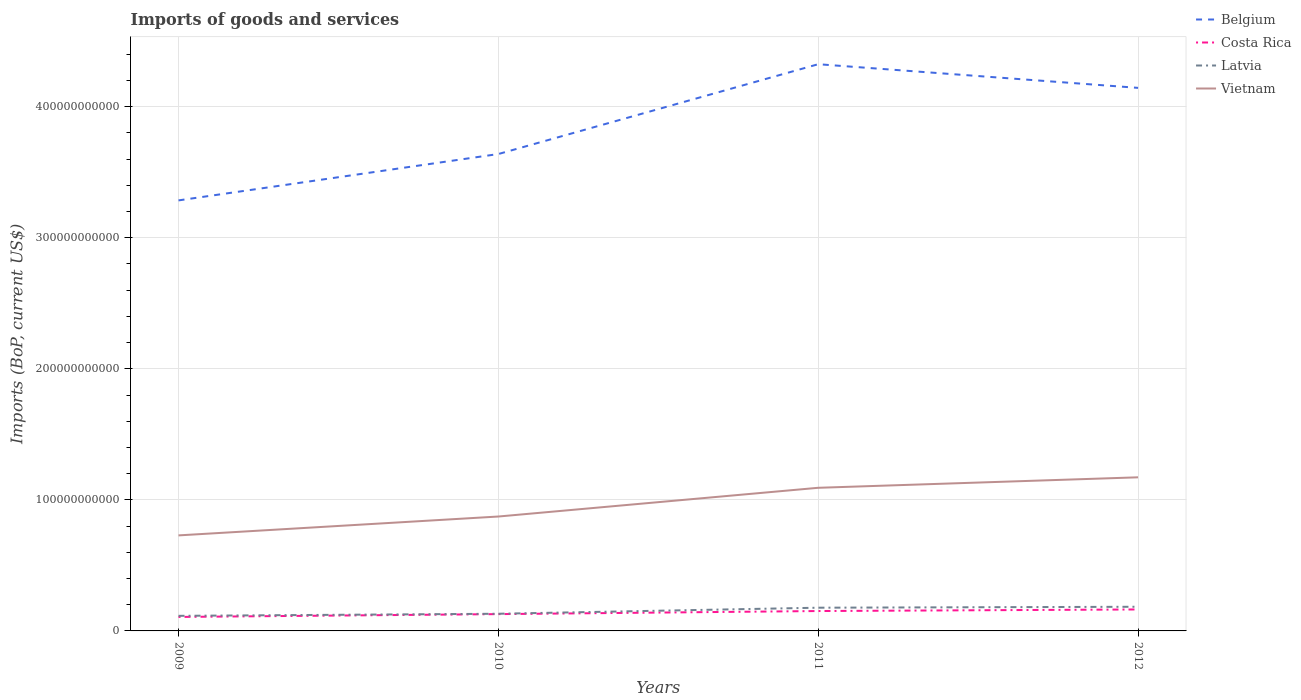How many different coloured lines are there?
Keep it short and to the point. 4. Does the line corresponding to Latvia intersect with the line corresponding to Vietnam?
Offer a very short reply. No. Across all years, what is the maximum amount spent on imports in Vietnam?
Provide a succinct answer. 7.29e+1. What is the total amount spent on imports in Vietnam in the graph?
Ensure brevity in your answer.  -1.44e+1. What is the difference between the highest and the second highest amount spent on imports in Costa Rica?
Offer a terse response. 5.72e+09. Is the amount spent on imports in Vietnam strictly greater than the amount spent on imports in Costa Rica over the years?
Offer a very short reply. No. What is the difference between two consecutive major ticks on the Y-axis?
Your answer should be very brief. 1.00e+11. Are the values on the major ticks of Y-axis written in scientific E-notation?
Your response must be concise. No. Does the graph contain grids?
Your answer should be compact. Yes. Where does the legend appear in the graph?
Provide a succinct answer. Top right. How many legend labels are there?
Make the answer very short. 4. How are the legend labels stacked?
Provide a succinct answer. Vertical. What is the title of the graph?
Offer a terse response. Imports of goods and services. What is the label or title of the Y-axis?
Provide a succinct answer. Imports (BoP, current US$). What is the Imports (BoP, current US$) in Belgium in 2009?
Your answer should be compact. 3.29e+11. What is the Imports (BoP, current US$) of Costa Rica in 2009?
Offer a terse response. 1.07e+1. What is the Imports (BoP, current US$) of Latvia in 2009?
Offer a very short reply. 1.15e+1. What is the Imports (BoP, current US$) in Vietnam in 2009?
Give a very brief answer. 7.29e+1. What is the Imports (BoP, current US$) of Belgium in 2010?
Offer a very short reply. 3.64e+11. What is the Imports (BoP, current US$) in Costa Rica in 2010?
Make the answer very short. 1.28e+1. What is the Imports (BoP, current US$) of Latvia in 2010?
Offer a terse response. 1.31e+1. What is the Imports (BoP, current US$) of Vietnam in 2010?
Offer a very short reply. 8.73e+1. What is the Imports (BoP, current US$) in Belgium in 2011?
Provide a short and direct response. 4.32e+11. What is the Imports (BoP, current US$) in Costa Rica in 2011?
Your answer should be very brief. 1.52e+1. What is the Imports (BoP, current US$) of Latvia in 2011?
Keep it short and to the point. 1.77e+1. What is the Imports (BoP, current US$) of Vietnam in 2011?
Your answer should be compact. 1.09e+11. What is the Imports (BoP, current US$) in Belgium in 2012?
Offer a terse response. 4.14e+11. What is the Imports (BoP, current US$) in Costa Rica in 2012?
Keep it short and to the point. 1.64e+1. What is the Imports (BoP, current US$) in Latvia in 2012?
Your answer should be compact. 1.84e+1. What is the Imports (BoP, current US$) in Vietnam in 2012?
Provide a short and direct response. 1.17e+11. Across all years, what is the maximum Imports (BoP, current US$) in Belgium?
Ensure brevity in your answer.  4.32e+11. Across all years, what is the maximum Imports (BoP, current US$) of Costa Rica?
Provide a succinct answer. 1.64e+1. Across all years, what is the maximum Imports (BoP, current US$) of Latvia?
Give a very brief answer. 1.84e+1. Across all years, what is the maximum Imports (BoP, current US$) of Vietnam?
Provide a succinct answer. 1.17e+11. Across all years, what is the minimum Imports (BoP, current US$) of Belgium?
Your response must be concise. 3.29e+11. Across all years, what is the minimum Imports (BoP, current US$) in Costa Rica?
Provide a succinct answer. 1.07e+1. Across all years, what is the minimum Imports (BoP, current US$) of Latvia?
Offer a terse response. 1.15e+1. Across all years, what is the minimum Imports (BoP, current US$) of Vietnam?
Make the answer very short. 7.29e+1. What is the total Imports (BoP, current US$) of Belgium in the graph?
Give a very brief answer. 1.54e+12. What is the total Imports (BoP, current US$) in Costa Rica in the graph?
Your answer should be compact. 5.50e+1. What is the total Imports (BoP, current US$) in Latvia in the graph?
Ensure brevity in your answer.  6.08e+1. What is the total Imports (BoP, current US$) in Vietnam in the graph?
Give a very brief answer. 3.87e+11. What is the difference between the Imports (BoP, current US$) of Belgium in 2009 and that in 2010?
Make the answer very short. -3.54e+1. What is the difference between the Imports (BoP, current US$) of Costa Rica in 2009 and that in 2010?
Offer a terse response. -2.16e+09. What is the difference between the Imports (BoP, current US$) of Latvia in 2009 and that in 2010?
Provide a short and direct response. -1.59e+09. What is the difference between the Imports (BoP, current US$) of Vietnam in 2009 and that in 2010?
Make the answer very short. -1.44e+1. What is the difference between the Imports (BoP, current US$) in Belgium in 2009 and that in 2011?
Offer a terse response. -1.04e+11. What is the difference between the Imports (BoP, current US$) of Costa Rica in 2009 and that in 2011?
Keep it short and to the point. -4.52e+09. What is the difference between the Imports (BoP, current US$) in Latvia in 2009 and that in 2011?
Your answer should be very brief. -6.20e+09. What is the difference between the Imports (BoP, current US$) of Vietnam in 2009 and that in 2011?
Your response must be concise. -3.63e+1. What is the difference between the Imports (BoP, current US$) in Belgium in 2009 and that in 2012?
Ensure brevity in your answer.  -8.59e+1. What is the difference between the Imports (BoP, current US$) of Costa Rica in 2009 and that in 2012?
Provide a succinct answer. -5.72e+09. What is the difference between the Imports (BoP, current US$) in Latvia in 2009 and that in 2012?
Your answer should be compact. -6.92e+09. What is the difference between the Imports (BoP, current US$) of Vietnam in 2009 and that in 2012?
Give a very brief answer. -4.43e+1. What is the difference between the Imports (BoP, current US$) of Belgium in 2010 and that in 2011?
Offer a very short reply. -6.85e+1. What is the difference between the Imports (BoP, current US$) in Costa Rica in 2010 and that in 2011?
Ensure brevity in your answer.  -2.36e+09. What is the difference between the Imports (BoP, current US$) in Latvia in 2010 and that in 2011?
Your response must be concise. -4.61e+09. What is the difference between the Imports (BoP, current US$) in Vietnam in 2010 and that in 2011?
Make the answer very short. -2.19e+1. What is the difference between the Imports (BoP, current US$) in Belgium in 2010 and that in 2012?
Offer a terse response. -5.05e+1. What is the difference between the Imports (BoP, current US$) in Costa Rica in 2010 and that in 2012?
Offer a terse response. -3.56e+09. What is the difference between the Imports (BoP, current US$) in Latvia in 2010 and that in 2012?
Provide a short and direct response. -5.33e+09. What is the difference between the Imports (BoP, current US$) in Vietnam in 2010 and that in 2012?
Make the answer very short. -2.99e+1. What is the difference between the Imports (BoP, current US$) of Belgium in 2011 and that in 2012?
Offer a terse response. 1.81e+1. What is the difference between the Imports (BoP, current US$) in Costa Rica in 2011 and that in 2012?
Offer a terse response. -1.20e+09. What is the difference between the Imports (BoP, current US$) of Latvia in 2011 and that in 2012?
Provide a short and direct response. -7.21e+08. What is the difference between the Imports (BoP, current US$) of Vietnam in 2011 and that in 2012?
Your response must be concise. -7.99e+09. What is the difference between the Imports (BoP, current US$) of Belgium in 2009 and the Imports (BoP, current US$) of Costa Rica in 2010?
Make the answer very short. 3.16e+11. What is the difference between the Imports (BoP, current US$) of Belgium in 2009 and the Imports (BoP, current US$) of Latvia in 2010?
Offer a terse response. 3.15e+11. What is the difference between the Imports (BoP, current US$) in Belgium in 2009 and the Imports (BoP, current US$) in Vietnam in 2010?
Your response must be concise. 2.41e+11. What is the difference between the Imports (BoP, current US$) of Costa Rica in 2009 and the Imports (BoP, current US$) of Latvia in 2010?
Your answer should be compact. -2.45e+09. What is the difference between the Imports (BoP, current US$) of Costa Rica in 2009 and the Imports (BoP, current US$) of Vietnam in 2010?
Give a very brief answer. -7.66e+1. What is the difference between the Imports (BoP, current US$) of Latvia in 2009 and the Imports (BoP, current US$) of Vietnam in 2010?
Keep it short and to the point. -7.58e+1. What is the difference between the Imports (BoP, current US$) in Belgium in 2009 and the Imports (BoP, current US$) in Costa Rica in 2011?
Your response must be concise. 3.13e+11. What is the difference between the Imports (BoP, current US$) of Belgium in 2009 and the Imports (BoP, current US$) of Latvia in 2011?
Your response must be concise. 3.11e+11. What is the difference between the Imports (BoP, current US$) of Belgium in 2009 and the Imports (BoP, current US$) of Vietnam in 2011?
Keep it short and to the point. 2.19e+11. What is the difference between the Imports (BoP, current US$) in Costa Rica in 2009 and the Imports (BoP, current US$) in Latvia in 2011?
Provide a short and direct response. -7.06e+09. What is the difference between the Imports (BoP, current US$) of Costa Rica in 2009 and the Imports (BoP, current US$) of Vietnam in 2011?
Ensure brevity in your answer.  -9.86e+1. What is the difference between the Imports (BoP, current US$) in Latvia in 2009 and the Imports (BoP, current US$) in Vietnam in 2011?
Provide a short and direct response. -9.77e+1. What is the difference between the Imports (BoP, current US$) of Belgium in 2009 and the Imports (BoP, current US$) of Costa Rica in 2012?
Your answer should be compact. 3.12e+11. What is the difference between the Imports (BoP, current US$) of Belgium in 2009 and the Imports (BoP, current US$) of Latvia in 2012?
Provide a succinct answer. 3.10e+11. What is the difference between the Imports (BoP, current US$) of Belgium in 2009 and the Imports (BoP, current US$) of Vietnam in 2012?
Provide a succinct answer. 2.11e+11. What is the difference between the Imports (BoP, current US$) of Costa Rica in 2009 and the Imports (BoP, current US$) of Latvia in 2012?
Keep it short and to the point. -7.78e+09. What is the difference between the Imports (BoP, current US$) in Costa Rica in 2009 and the Imports (BoP, current US$) in Vietnam in 2012?
Your answer should be very brief. -1.07e+11. What is the difference between the Imports (BoP, current US$) in Latvia in 2009 and the Imports (BoP, current US$) in Vietnam in 2012?
Make the answer very short. -1.06e+11. What is the difference between the Imports (BoP, current US$) of Belgium in 2010 and the Imports (BoP, current US$) of Costa Rica in 2011?
Provide a succinct answer. 3.49e+11. What is the difference between the Imports (BoP, current US$) in Belgium in 2010 and the Imports (BoP, current US$) in Latvia in 2011?
Provide a short and direct response. 3.46e+11. What is the difference between the Imports (BoP, current US$) in Belgium in 2010 and the Imports (BoP, current US$) in Vietnam in 2011?
Your answer should be compact. 2.55e+11. What is the difference between the Imports (BoP, current US$) in Costa Rica in 2010 and the Imports (BoP, current US$) in Latvia in 2011?
Ensure brevity in your answer.  -4.90e+09. What is the difference between the Imports (BoP, current US$) in Costa Rica in 2010 and the Imports (BoP, current US$) in Vietnam in 2011?
Give a very brief answer. -9.64e+1. What is the difference between the Imports (BoP, current US$) in Latvia in 2010 and the Imports (BoP, current US$) in Vietnam in 2011?
Provide a succinct answer. -9.61e+1. What is the difference between the Imports (BoP, current US$) of Belgium in 2010 and the Imports (BoP, current US$) of Costa Rica in 2012?
Provide a succinct answer. 3.48e+11. What is the difference between the Imports (BoP, current US$) of Belgium in 2010 and the Imports (BoP, current US$) of Latvia in 2012?
Your answer should be compact. 3.45e+11. What is the difference between the Imports (BoP, current US$) of Belgium in 2010 and the Imports (BoP, current US$) of Vietnam in 2012?
Your answer should be compact. 2.47e+11. What is the difference between the Imports (BoP, current US$) of Costa Rica in 2010 and the Imports (BoP, current US$) of Latvia in 2012?
Your response must be concise. -5.62e+09. What is the difference between the Imports (BoP, current US$) in Costa Rica in 2010 and the Imports (BoP, current US$) in Vietnam in 2012?
Your response must be concise. -1.04e+11. What is the difference between the Imports (BoP, current US$) in Latvia in 2010 and the Imports (BoP, current US$) in Vietnam in 2012?
Your answer should be very brief. -1.04e+11. What is the difference between the Imports (BoP, current US$) of Belgium in 2011 and the Imports (BoP, current US$) of Costa Rica in 2012?
Give a very brief answer. 4.16e+11. What is the difference between the Imports (BoP, current US$) of Belgium in 2011 and the Imports (BoP, current US$) of Latvia in 2012?
Ensure brevity in your answer.  4.14e+11. What is the difference between the Imports (BoP, current US$) of Belgium in 2011 and the Imports (BoP, current US$) of Vietnam in 2012?
Provide a succinct answer. 3.15e+11. What is the difference between the Imports (BoP, current US$) in Costa Rica in 2011 and the Imports (BoP, current US$) in Latvia in 2012?
Your answer should be very brief. -3.26e+09. What is the difference between the Imports (BoP, current US$) of Costa Rica in 2011 and the Imports (BoP, current US$) of Vietnam in 2012?
Ensure brevity in your answer.  -1.02e+11. What is the difference between the Imports (BoP, current US$) in Latvia in 2011 and the Imports (BoP, current US$) in Vietnam in 2012?
Your response must be concise. -9.95e+1. What is the average Imports (BoP, current US$) in Belgium per year?
Offer a very short reply. 3.85e+11. What is the average Imports (BoP, current US$) in Costa Rica per year?
Your answer should be compact. 1.38e+1. What is the average Imports (BoP, current US$) in Latvia per year?
Provide a succinct answer. 1.52e+1. What is the average Imports (BoP, current US$) of Vietnam per year?
Offer a terse response. 9.67e+1. In the year 2009, what is the difference between the Imports (BoP, current US$) of Belgium and Imports (BoP, current US$) of Costa Rica?
Offer a very short reply. 3.18e+11. In the year 2009, what is the difference between the Imports (BoP, current US$) of Belgium and Imports (BoP, current US$) of Latvia?
Offer a very short reply. 3.17e+11. In the year 2009, what is the difference between the Imports (BoP, current US$) of Belgium and Imports (BoP, current US$) of Vietnam?
Make the answer very short. 2.56e+11. In the year 2009, what is the difference between the Imports (BoP, current US$) of Costa Rica and Imports (BoP, current US$) of Latvia?
Keep it short and to the point. -8.57e+08. In the year 2009, what is the difference between the Imports (BoP, current US$) in Costa Rica and Imports (BoP, current US$) in Vietnam?
Offer a terse response. -6.22e+1. In the year 2009, what is the difference between the Imports (BoP, current US$) in Latvia and Imports (BoP, current US$) in Vietnam?
Your answer should be very brief. -6.14e+1. In the year 2010, what is the difference between the Imports (BoP, current US$) in Belgium and Imports (BoP, current US$) in Costa Rica?
Keep it short and to the point. 3.51e+11. In the year 2010, what is the difference between the Imports (BoP, current US$) of Belgium and Imports (BoP, current US$) of Latvia?
Offer a terse response. 3.51e+11. In the year 2010, what is the difference between the Imports (BoP, current US$) of Belgium and Imports (BoP, current US$) of Vietnam?
Your response must be concise. 2.77e+11. In the year 2010, what is the difference between the Imports (BoP, current US$) in Costa Rica and Imports (BoP, current US$) in Latvia?
Your answer should be compact. -2.86e+08. In the year 2010, what is the difference between the Imports (BoP, current US$) in Costa Rica and Imports (BoP, current US$) in Vietnam?
Keep it short and to the point. -7.45e+1. In the year 2010, what is the difference between the Imports (BoP, current US$) of Latvia and Imports (BoP, current US$) of Vietnam?
Ensure brevity in your answer.  -7.42e+1. In the year 2011, what is the difference between the Imports (BoP, current US$) of Belgium and Imports (BoP, current US$) of Costa Rica?
Make the answer very short. 4.17e+11. In the year 2011, what is the difference between the Imports (BoP, current US$) in Belgium and Imports (BoP, current US$) in Latvia?
Offer a terse response. 4.15e+11. In the year 2011, what is the difference between the Imports (BoP, current US$) of Belgium and Imports (BoP, current US$) of Vietnam?
Provide a short and direct response. 3.23e+11. In the year 2011, what is the difference between the Imports (BoP, current US$) of Costa Rica and Imports (BoP, current US$) of Latvia?
Provide a short and direct response. -2.54e+09. In the year 2011, what is the difference between the Imports (BoP, current US$) in Costa Rica and Imports (BoP, current US$) in Vietnam?
Provide a short and direct response. -9.40e+1. In the year 2011, what is the difference between the Imports (BoP, current US$) in Latvia and Imports (BoP, current US$) in Vietnam?
Your response must be concise. -9.15e+1. In the year 2012, what is the difference between the Imports (BoP, current US$) in Belgium and Imports (BoP, current US$) in Costa Rica?
Your answer should be compact. 3.98e+11. In the year 2012, what is the difference between the Imports (BoP, current US$) of Belgium and Imports (BoP, current US$) of Latvia?
Keep it short and to the point. 3.96e+11. In the year 2012, what is the difference between the Imports (BoP, current US$) of Belgium and Imports (BoP, current US$) of Vietnam?
Provide a short and direct response. 2.97e+11. In the year 2012, what is the difference between the Imports (BoP, current US$) in Costa Rica and Imports (BoP, current US$) in Latvia?
Provide a short and direct response. -2.06e+09. In the year 2012, what is the difference between the Imports (BoP, current US$) of Costa Rica and Imports (BoP, current US$) of Vietnam?
Your answer should be compact. -1.01e+11. In the year 2012, what is the difference between the Imports (BoP, current US$) in Latvia and Imports (BoP, current US$) in Vietnam?
Offer a terse response. -9.88e+1. What is the ratio of the Imports (BoP, current US$) in Belgium in 2009 to that in 2010?
Provide a short and direct response. 0.9. What is the ratio of the Imports (BoP, current US$) of Costa Rica in 2009 to that in 2010?
Provide a short and direct response. 0.83. What is the ratio of the Imports (BoP, current US$) in Latvia in 2009 to that in 2010?
Your answer should be very brief. 0.88. What is the ratio of the Imports (BoP, current US$) in Vietnam in 2009 to that in 2010?
Give a very brief answer. 0.83. What is the ratio of the Imports (BoP, current US$) in Belgium in 2009 to that in 2011?
Give a very brief answer. 0.76. What is the ratio of the Imports (BoP, current US$) in Costa Rica in 2009 to that in 2011?
Your answer should be compact. 0.7. What is the ratio of the Imports (BoP, current US$) in Latvia in 2009 to that in 2011?
Keep it short and to the point. 0.65. What is the ratio of the Imports (BoP, current US$) of Vietnam in 2009 to that in 2011?
Offer a very short reply. 0.67. What is the ratio of the Imports (BoP, current US$) in Belgium in 2009 to that in 2012?
Your answer should be compact. 0.79. What is the ratio of the Imports (BoP, current US$) in Costa Rica in 2009 to that in 2012?
Ensure brevity in your answer.  0.65. What is the ratio of the Imports (BoP, current US$) of Latvia in 2009 to that in 2012?
Keep it short and to the point. 0.62. What is the ratio of the Imports (BoP, current US$) in Vietnam in 2009 to that in 2012?
Your response must be concise. 0.62. What is the ratio of the Imports (BoP, current US$) in Belgium in 2010 to that in 2011?
Offer a very short reply. 0.84. What is the ratio of the Imports (BoP, current US$) in Costa Rica in 2010 to that in 2011?
Provide a short and direct response. 0.84. What is the ratio of the Imports (BoP, current US$) of Latvia in 2010 to that in 2011?
Ensure brevity in your answer.  0.74. What is the ratio of the Imports (BoP, current US$) in Vietnam in 2010 to that in 2011?
Make the answer very short. 0.8. What is the ratio of the Imports (BoP, current US$) in Belgium in 2010 to that in 2012?
Give a very brief answer. 0.88. What is the ratio of the Imports (BoP, current US$) of Costa Rica in 2010 to that in 2012?
Make the answer very short. 0.78. What is the ratio of the Imports (BoP, current US$) in Latvia in 2010 to that in 2012?
Ensure brevity in your answer.  0.71. What is the ratio of the Imports (BoP, current US$) in Vietnam in 2010 to that in 2012?
Offer a terse response. 0.74. What is the ratio of the Imports (BoP, current US$) in Belgium in 2011 to that in 2012?
Provide a succinct answer. 1.04. What is the ratio of the Imports (BoP, current US$) of Costa Rica in 2011 to that in 2012?
Give a very brief answer. 0.93. What is the ratio of the Imports (BoP, current US$) in Latvia in 2011 to that in 2012?
Offer a very short reply. 0.96. What is the ratio of the Imports (BoP, current US$) in Vietnam in 2011 to that in 2012?
Provide a succinct answer. 0.93. What is the difference between the highest and the second highest Imports (BoP, current US$) of Belgium?
Your answer should be very brief. 1.81e+1. What is the difference between the highest and the second highest Imports (BoP, current US$) in Costa Rica?
Provide a succinct answer. 1.20e+09. What is the difference between the highest and the second highest Imports (BoP, current US$) in Latvia?
Ensure brevity in your answer.  7.21e+08. What is the difference between the highest and the second highest Imports (BoP, current US$) of Vietnam?
Ensure brevity in your answer.  7.99e+09. What is the difference between the highest and the lowest Imports (BoP, current US$) of Belgium?
Keep it short and to the point. 1.04e+11. What is the difference between the highest and the lowest Imports (BoP, current US$) of Costa Rica?
Provide a short and direct response. 5.72e+09. What is the difference between the highest and the lowest Imports (BoP, current US$) in Latvia?
Give a very brief answer. 6.92e+09. What is the difference between the highest and the lowest Imports (BoP, current US$) in Vietnam?
Offer a very short reply. 4.43e+1. 